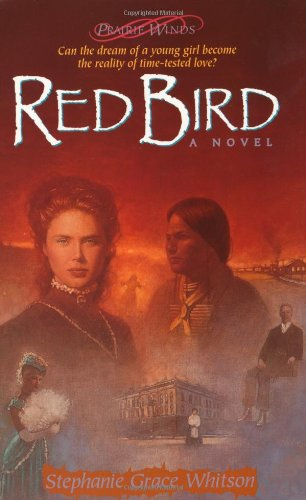What time period is 'Red Bird' set in? 'Red Bird' is set during the early pioneering times of America, vividly bringing to life the challenges and experiences of the era. 